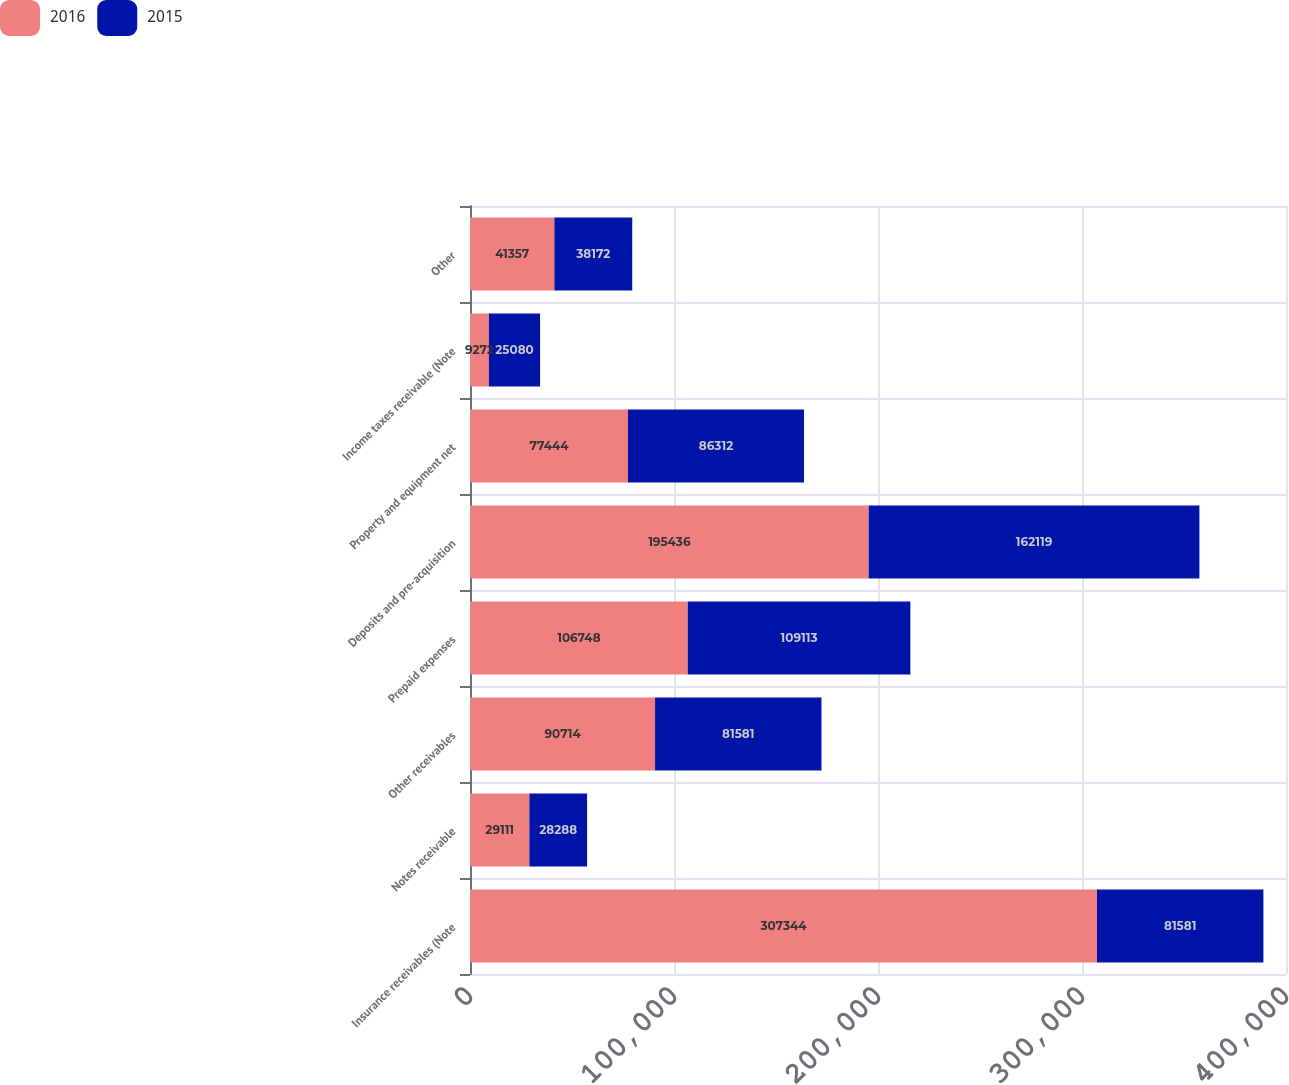<chart> <loc_0><loc_0><loc_500><loc_500><stacked_bar_chart><ecel><fcel>Insurance receivables (Note<fcel>Notes receivable<fcel>Other receivables<fcel>Prepaid expenses<fcel>Deposits and pre-acquisition<fcel>Property and equipment net<fcel>Income taxes receivable (Note<fcel>Other<nl><fcel>2016<fcel>307344<fcel>29111<fcel>90714<fcel>106748<fcel>195436<fcel>77444<fcel>9272<fcel>41357<nl><fcel>2015<fcel>81581<fcel>28288<fcel>81581<fcel>109113<fcel>162119<fcel>86312<fcel>25080<fcel>38172<nl></chart> 